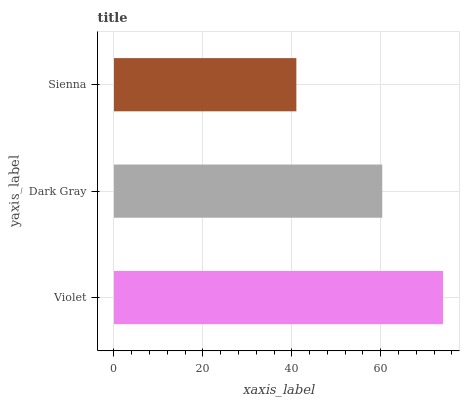Is Sienna the minimum?
Answer yes or no. Yes. Is Violet the maximum?
Answer yes or no. Yes. Is Dark Gray the minimum?
Answer yes or no. No. Is Dark Gray the maximum?
Answer yes or no. No. Is Violet greater than Dark Gray?
Answer yes or no. Yes. Is Dark Gray less than Violet?
Answer yes or no. Yes. Is Dark Gray greater than Violet?
Answer yes or no. No. Is Violet less than Dark Gray?
Answer yes or no. No. Is Dark Gray the high median?
Answer yes or no. Yes. Is Dark Gray the low median?
Answer yes or no. Yes. Is Violet the high median?
Answer yes or no. No. Is Sienna the low median?
Answer yes or no. No. 